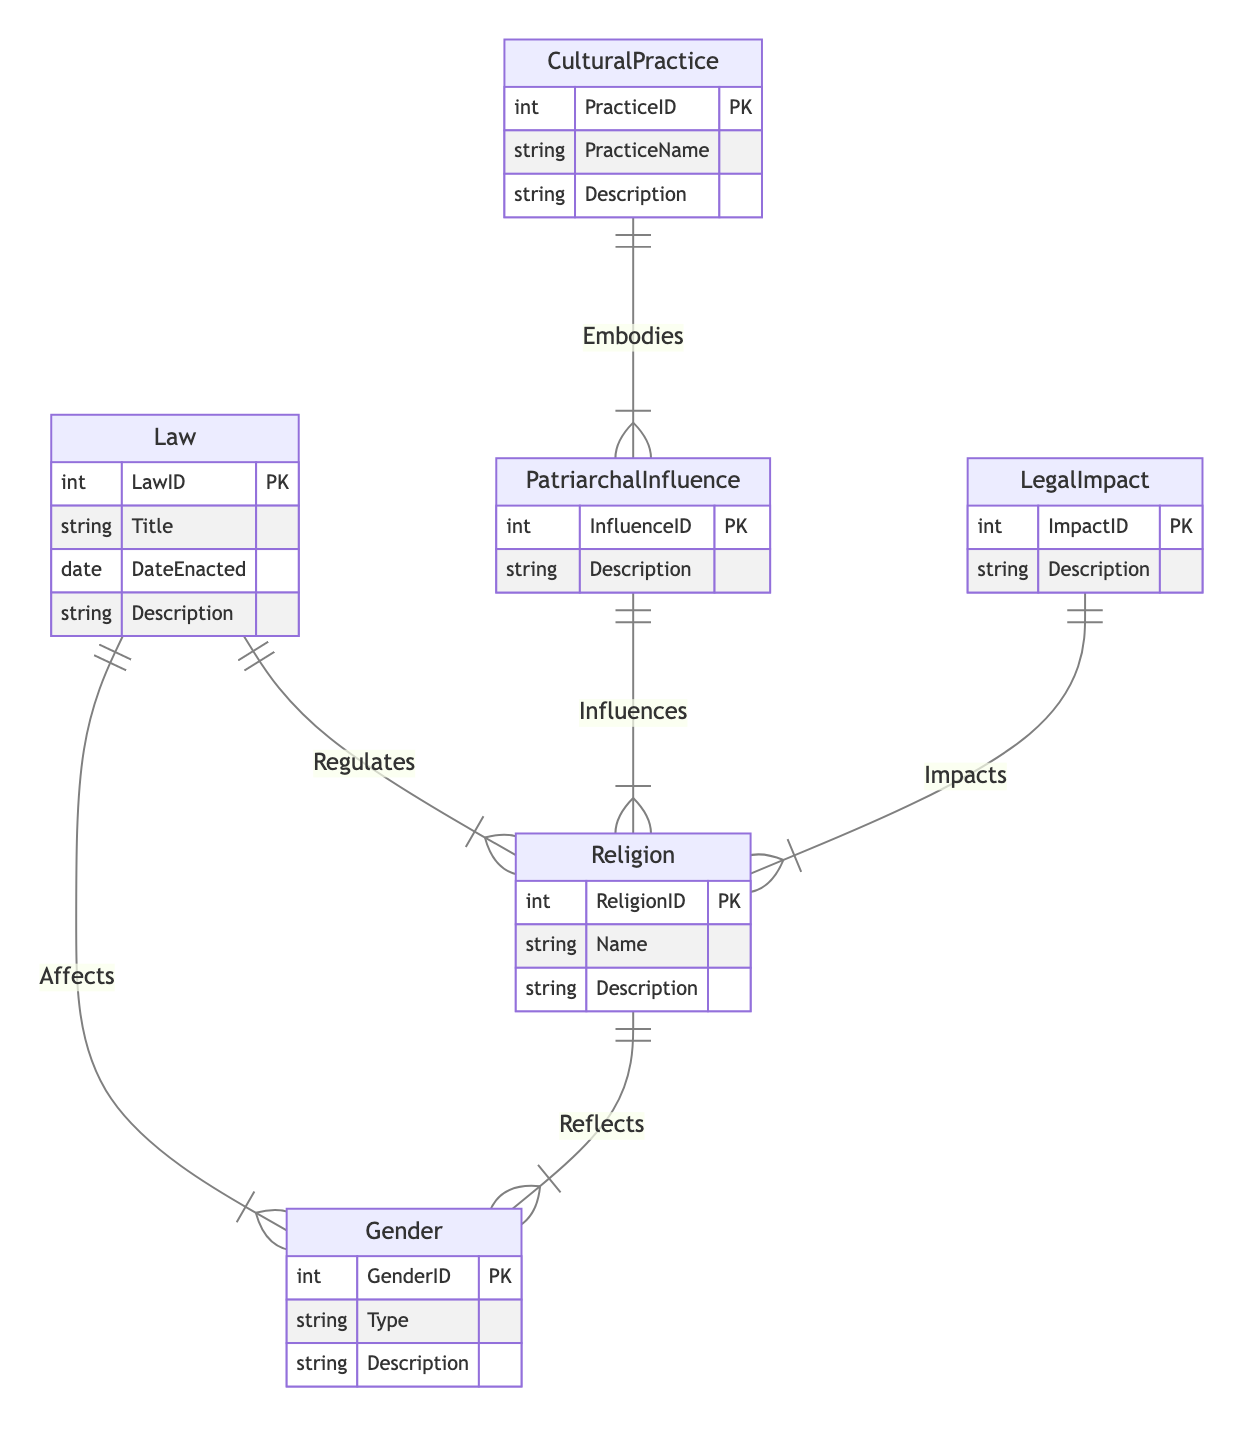What is the primary entity related to the "Law" in the diagram? The primary entity related to "Law" in the diagram is "Religion," as there is a direct relationship named "Regulates" connecting them.
Answer: Religion How many entities are present in the diagram? The diagram consists of six entities: Law, Religion, Gender, LegalImpact, PatriarchalInfluence, and CulturalPractice.
Answer: 6 Which gender entity is connected to the law through the relationship "Affects"? The entity connected to "Law" through the relationship "Affects" is "Gender." This indicates that laws impact gender representations.
Answer: Gender What entity embodies patriarchal influence? The entity that embodies patriarchal influence is "CulturalPractice," establishing a link between cultural actions and patriarchal systems.
Answer: CulturalPractice Which relationship exists between "Religion" and "Gender"? The relationship that exists between "Religion" and "Gender" is named "Reflects," illustrating how religious beliefs can reflect gender representations.
Answer: Reflects What type of influence is associated with the "Religion" entity in this diagram? The type of influence associated with the "Religion" entity is "PatriarchalInfluence," which indicates that patriarchal systems have a role in shaping religious practices.
Answer: PatriarchalInfluence How many relationships are depicted in the diagram? The diagram depicts six relationships: Regulates, Affects, Influences, Impacts, Embodies, and Reflects, connecting the various entities.
Answer: 6 Which legal impact relates directly to the "Religion" entity? The legal impact that relates directly to the "Religion" entity is represented by the relationship "Impacts," showing how legal decisions affect religious practices.
Answer: Impacts What does the relationship "Influences" connect? The relationship "Influences" connects "PatriarchalInfluence" and "Religion," indicating that patriarchal structures shape religious beliefs and practices.
Answer: Influences What is the attribute that describes the "Law" entity? One of the attributes that describes the "Law" entity is "Description," which provides information about the law's content and implications.
Answer: Description 